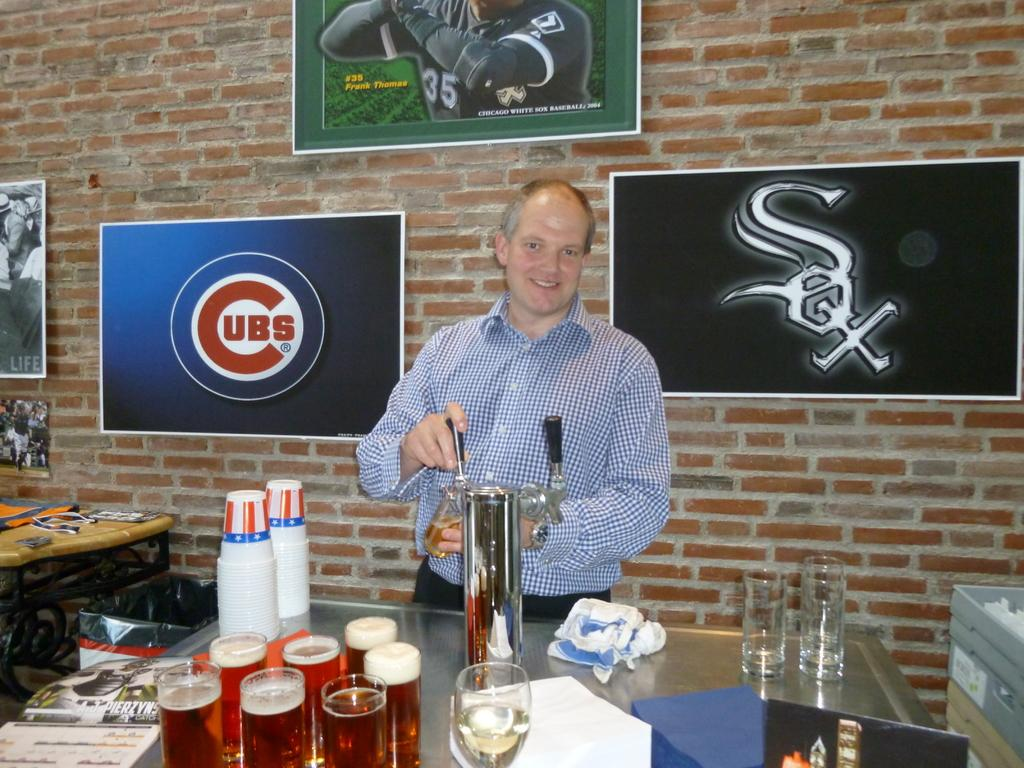<image>
Create a compact narrative representing the image presented. A man is pouring beer out of a tap and behind him are logos for both the Cubs and Sox. 